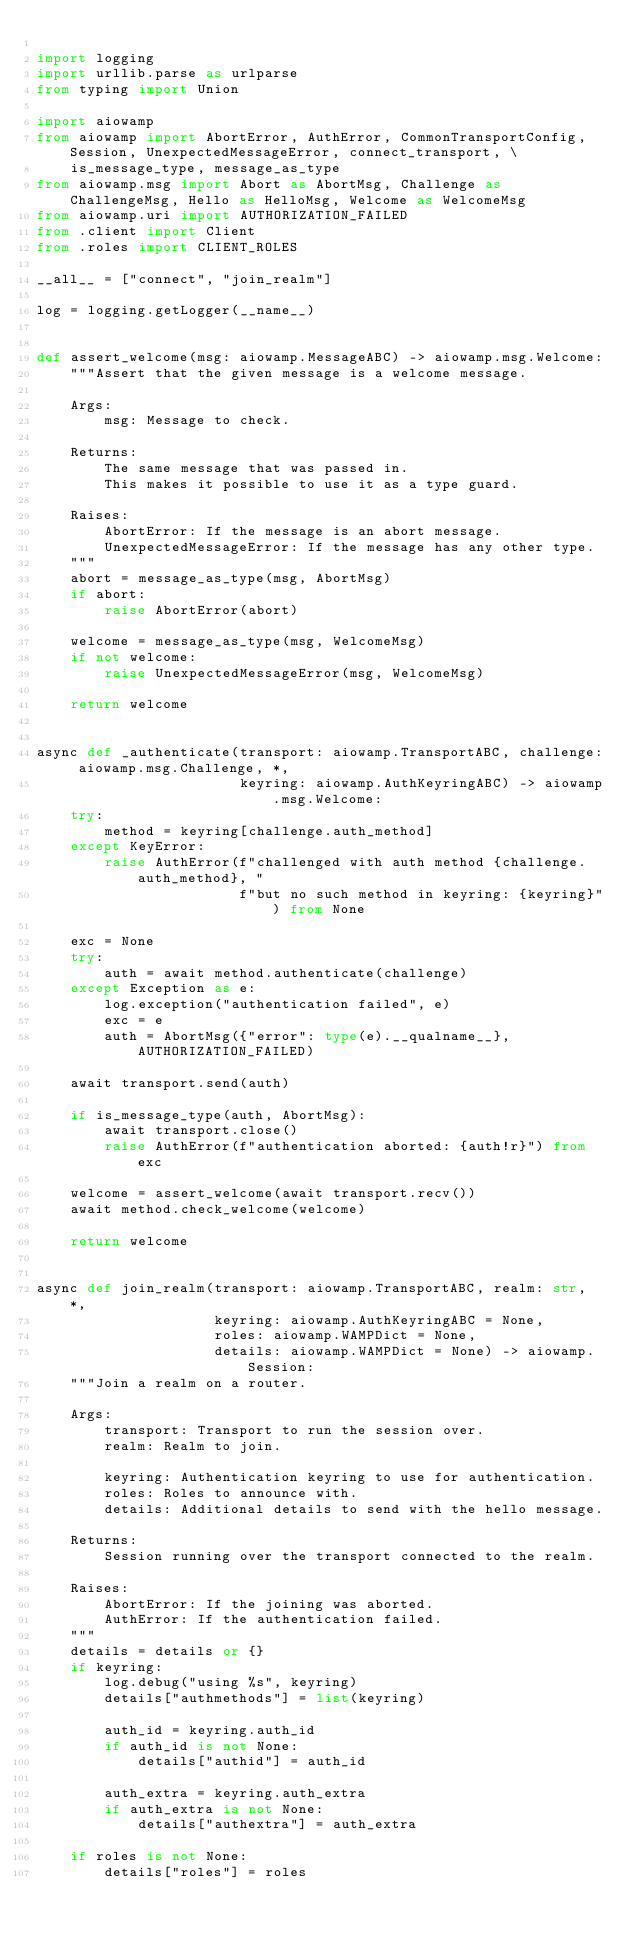Convert code to text. <code><loc_0><loc_0><loc_500><loc_500><_Python_>
import logging
import urllib.parse as urlparse
from typing import Union

import aiowamp
from aiowamp import AbortError, AuthError, CommonTransportConfig, Session, UnexpectedMessageError, connect_transport, \
    is_message_type, message_as_type
from aiowamp.msg import Abort as AbortMsg, Challenge as ChallengeMsg, Hello as HelloMsg, Welcome as WelcomeMsg
from aiowamp.uri import AUTHORIZATION_FAILED
from .client import Client
from .roles import CLIENT_ROLES

__all__ = ["connect", "join_realm"]

log = logging.getLogger(__name__)


def assert_welcome(msg: aiowamp.MessageABC) -> aiowamp.msg.Welcome:
    """Assert that the given message is a welcome message.

    Args:
        msg: Message to check.

    Returns:
        The same message that was passed in.
        This makes it possible to use it as a type guard.

    Raises:
        AbortError: If the message is an abort message.
        UnexpectedMessageError: If the message has any other type.
    """
    abort = message_as_type(msg, AbortMsg)
    if abort:
        raise AbortError(abort)

    welcome = message_as_type(msg, WelcomeMsg)
    if not welcome:
        raise UnexpectedMessageError(msg, WelcomeMsg)

    return welcome


async def _authenticate(transport: aiowamp.TransportABC, challenge: aiowamp.msg.Challenge, *,
                        keyring: aiowamp.AuthKeyringABC) -> aiowamp.msg.Welcome:
    try:
        method = keyring[challenge.auth_method]
    except KeyError:
        raise AuthError(f"challenged with auth method {challenge.auth_method}, "
                        f"but no such method in keyring: {keyring}") from None

    exc = None
    try:
        auth = await method.authenticate(challenge)
    except Exception as e:
        log.exception("authentication failed", e)
        exc = e
        auth = AbortMsg({"error": type(e).__qualname__}, AUTHORIZATION_FAILED)

    await transport.send(auth)

    if is_message_type(auth, AbortMsg):
        await transport.close()
        raise AuthError(f"authentication aborted: {auth!r}") from exc

    welcome = assert_welcome(await transport.recv())
    await method.check_welcome(welcome)

    return welcome


async def join_realm(transport: aiowamp.TransportABC, realm: str, *,
                     keyring: aiowamp.AuthKeyringABC = None,
                     roles: aiowamp.WAMPDict = None,
                     details: aiowamp.WAMPDict = None) -> aiowamp.Session:
    """Join a realm on a router.

    Args:
        transport: Transport to run the session over.
        realm: Realm to join.

        keyring: Authentication keyring to use for authentication.
        roles: Roles to announce with.
        details: Additional details to send with the hello message.

    Returns:
        Session running over the transport connected to the realm.

    Raises:
        AbortError: If the joining was aborted.
        AuthError: If the authentication failed.
    """
    details = details or {}
    if keyring:
        log.debug("using %s", keyring)
        details["authmethods"] = list(keyring)

        auth_id = keyring.auth_id
        if auth_id is not None:
            details["authid"] = auth_id

        auth_extra = keyring.auth_extra
        if auth_extra is not None:
            details["authextra"] = auth_extra

    if roles is not None:
        details["roles"] = roles
</code> 